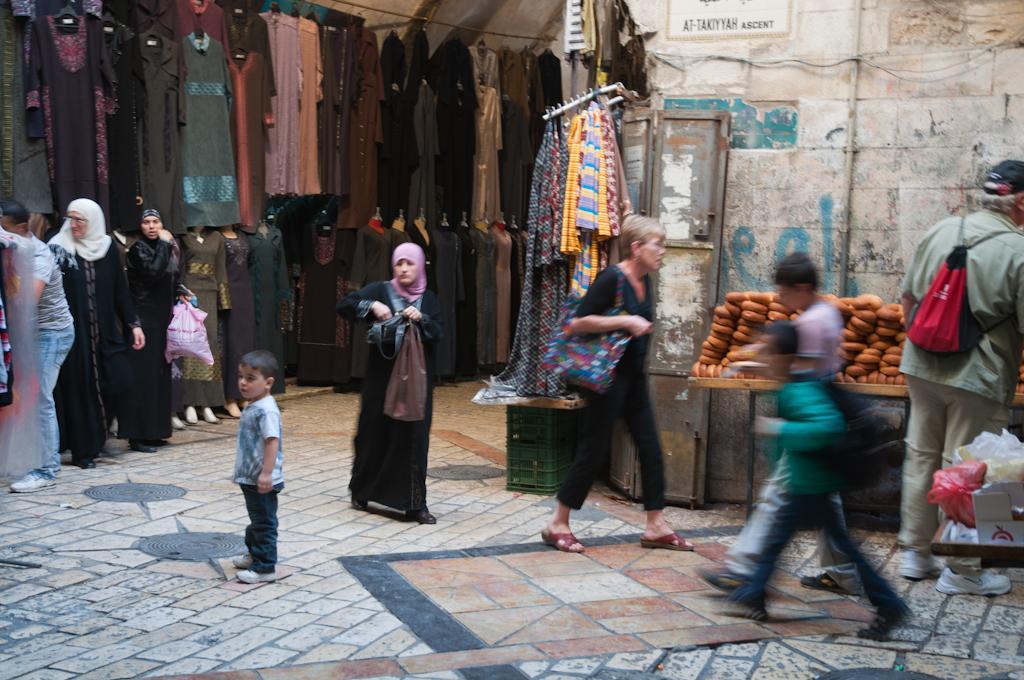How would you summarize this image in a sentence or two? In this picture we can observe some women, men and children walking. Most of them were wearing black color dresses. We can observe some clothes hanged to the hangers. In the background there is a wall which is in white color. 